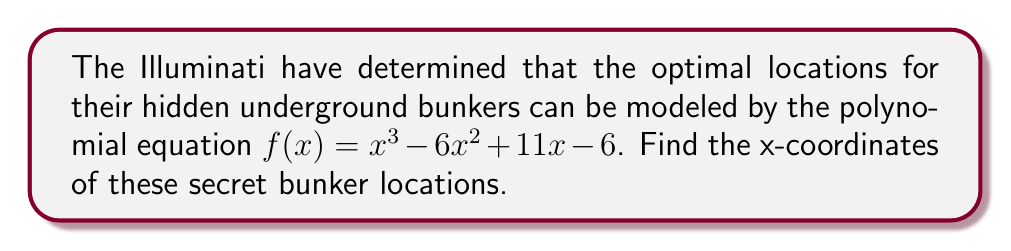Could you help me with this problem? To find the optimal locations for the underground bunkers, we need to identify the roots of the given polynomial equation. These roots represent the x-coordinates where $f(x) = 0$.

Let's solve this step-by-step:

1) First, we can try to factor the polynomial:
   $f(x) = x^3 - 6x^2 + 11x - 6$
   
2) We can see that 1 is a factor (you can verify this by plugging in 1 for x):
   $f(x) = (x - 1)(x^2 - 5x + 6)$
   
3) Now we can factor the quadratic term:
   $f(x) = (x - 1)(x - 2)(x - 3)$
   
4) The roots of the polynomial are the values of x that make each factor equal to zero:
   $x - 1 = 0$, $x - 2 = 0$, $x - 3 = 0$
   
5) Solving these equations:
   $x = 1$, $x = 2$, $x = 3$

Therefore, the x-coordinates of the optimal locations for the hidden underground bunkers are 1, 2, and 3.

[asy]
size(200);
import graph;

real f(real x) {return x^3 - 6x^2 + 11x - 6;}

draw(graph(f,-0.5,3.5), blue);
draw((-0.5,0)--(3.5,0), arrow=Arrow);
draw((0,-2)--(0,10), arrow=Arrow);

dot((1,0));
dot((2,0));
dot((3,0));

label("1", (1,0), S);
label("2", (2,0), S);
label("3", (3,0), S);
[/asy]
Answer: The x-coordinates of the optimal locations for the hidden underground bunkers are $x = 1$, $x = 2$, and $x = 3$. 